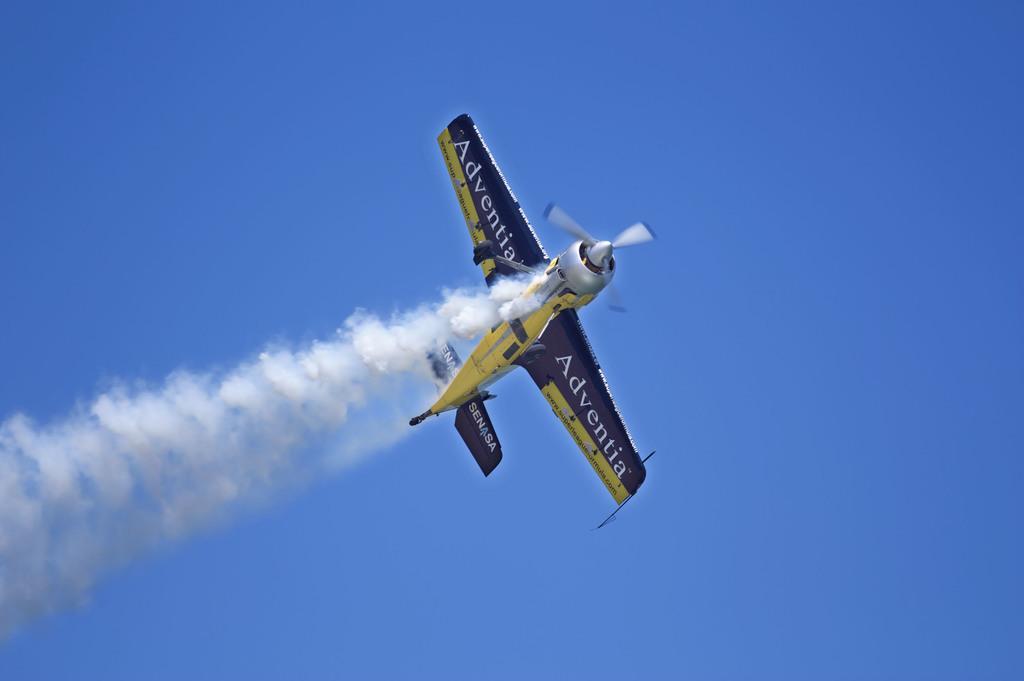Can you describe this image briefly? In this image there is a flight in the sky and there is a smoke. 